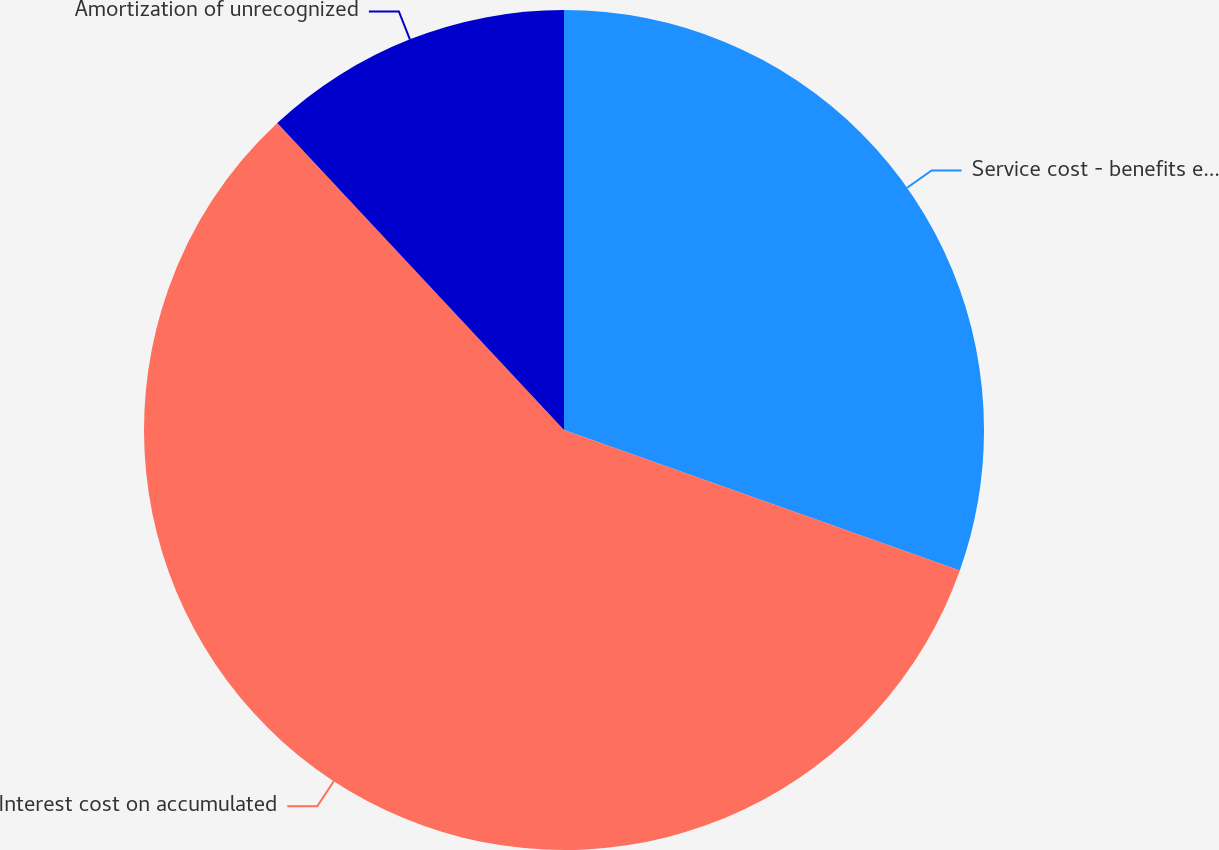Convert chart. <chart><loc_0><loc_0><loc_500><loc_500><pie_chart><fcel>Service cost - benefits earned<fcel>Interest cost on accumulated<fcel>Amortization of unrecognized<nl><fcel>30.43%<fcel>57.61%<fcel>11.96%<nl></chart> 